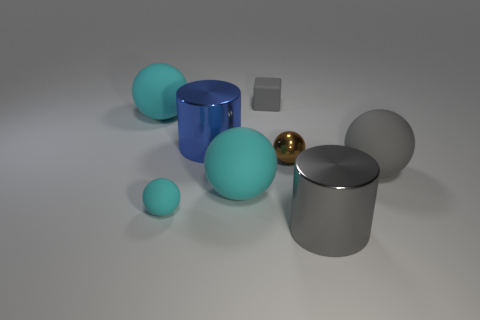How many cyan balls must be subtracted to get 1 cyan balls? 2 Subtract all gray rubber balls. How many balls are left? 4 Subtract all cyan spheres. How many spheres are left? 2 Subtract all cylinders. How many objects are left? 6 Add 2 big rubber balls. How many objects exist? 10 Subtract all brown blocks. How many green cylinders are left? 0 Add 1 big gray cylinders. How many big gray cylinders exist? 2 Subtract 1 gray spheres. How many objects are left? 7 Subtract 1 blocks. How many blocks are left? 0 Subtract all blue cylinders. Subtract all blue spheres. How many cylinders are left? 1 